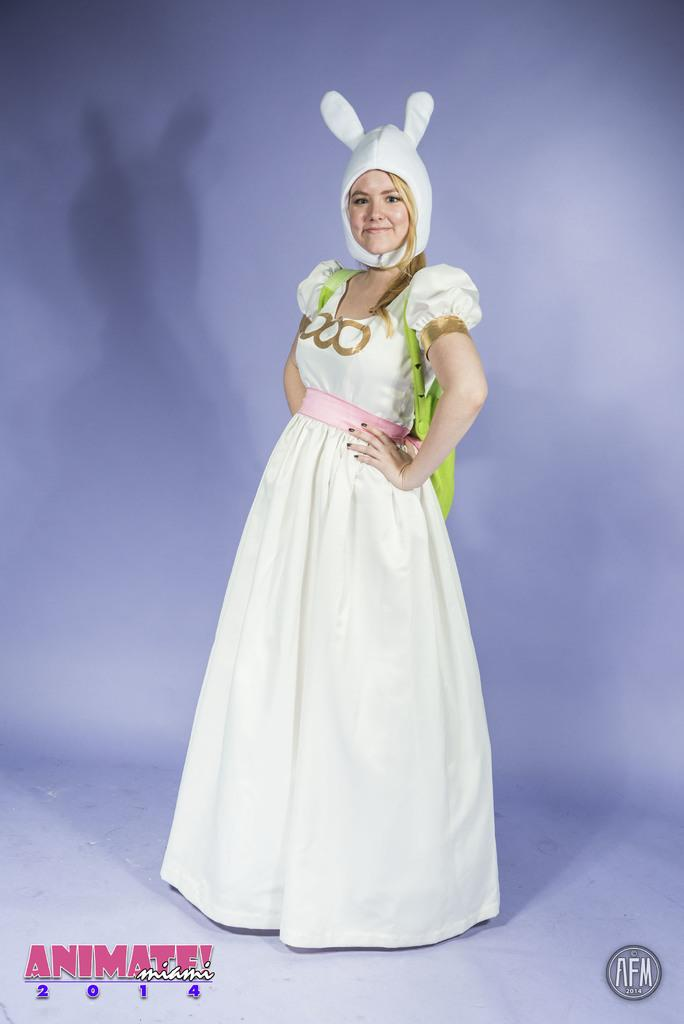Who is the main subject in the image? There is a woman in the image. What is the woman wearing? The woman is wearing a white frock and a white hat. Is there any text present in the image? Yes, there is text at the bottom of the image. What type of soap is the woman holding in the image? There is no soap present in the image; the woman is wearing a white frock and a white hat. Can you see a kitty playing with a pen in the image? There is no kitty or pen present in the image. 